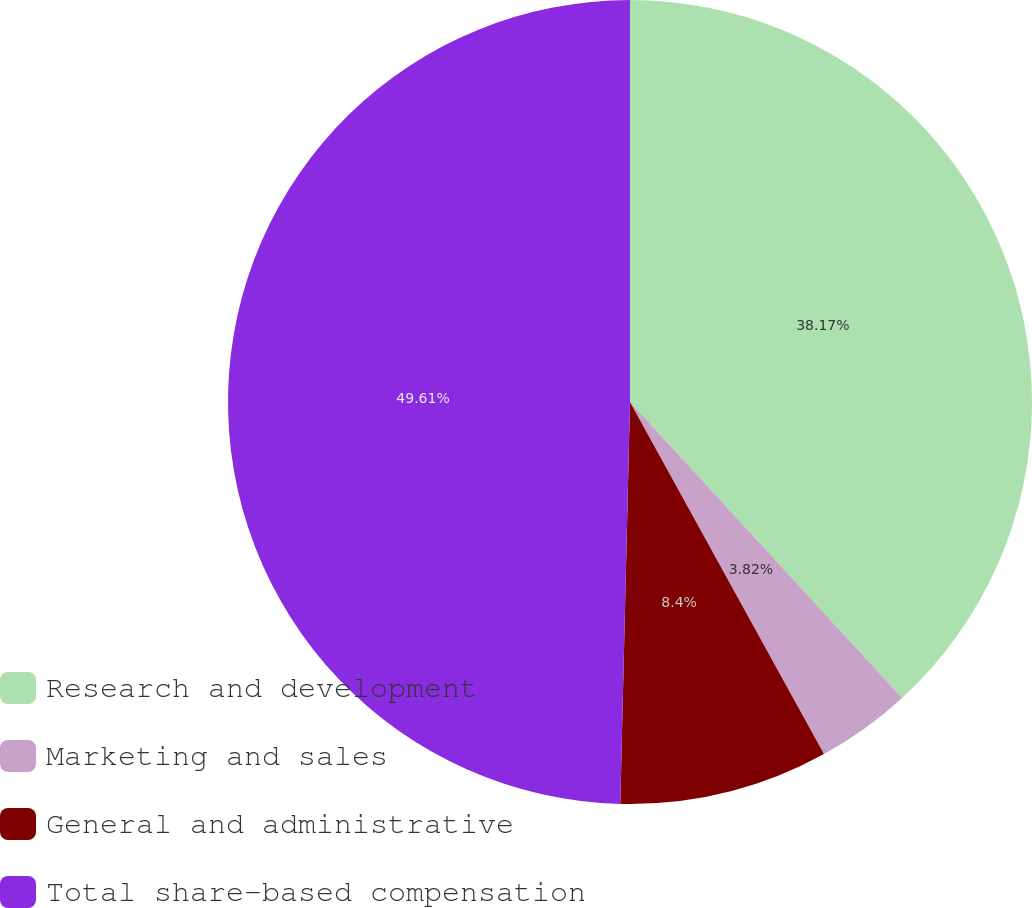Convert chart to OTSL. <chart><loc_0><loc_0><loc_500><loc_500><pie_chart><fcel>Research and development<fcel>Marketing and sales<fcel>General and administrative<fcel>Total share-based compensation<nl><fcel>38.17%<fcel>3.82%<fcel>8.4%<fcel>49.62%<nl></chart> 